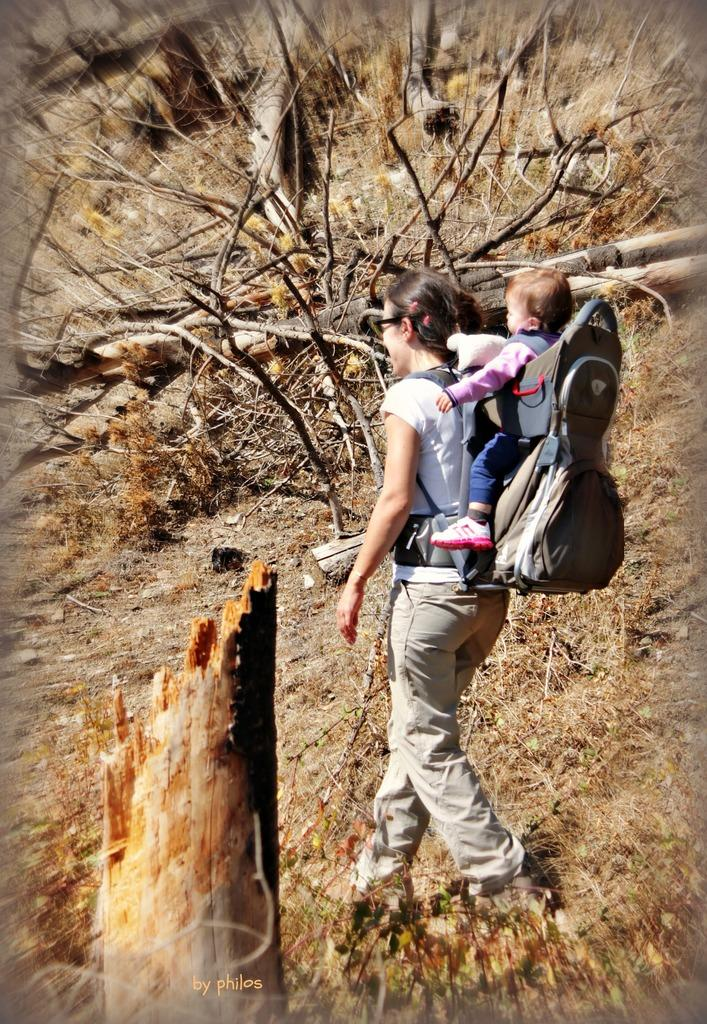Who is the main subject in the image? There is a lady in the image. What is the lady doing in the image? The lady is carrying a baby on her back. What can be seen on the ground in the image? There are many twigs, wooden logs, and leaves on the ground. Can you hear the ladybug laughing in the image? There is no ladybug present in the image, and therefore no laughter can be heard. 